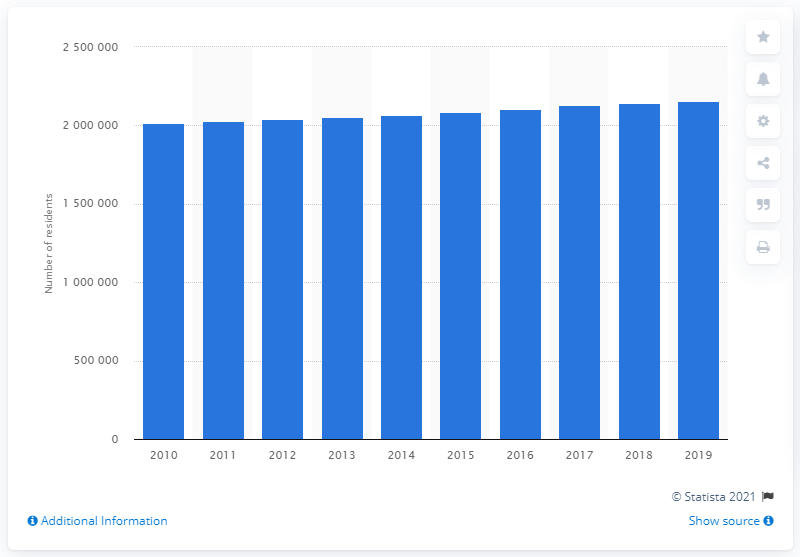List a handful of essential elements in this visual. In 2019, the Kansas City metropolitan area had a population of approximately 2,144,427 people. 